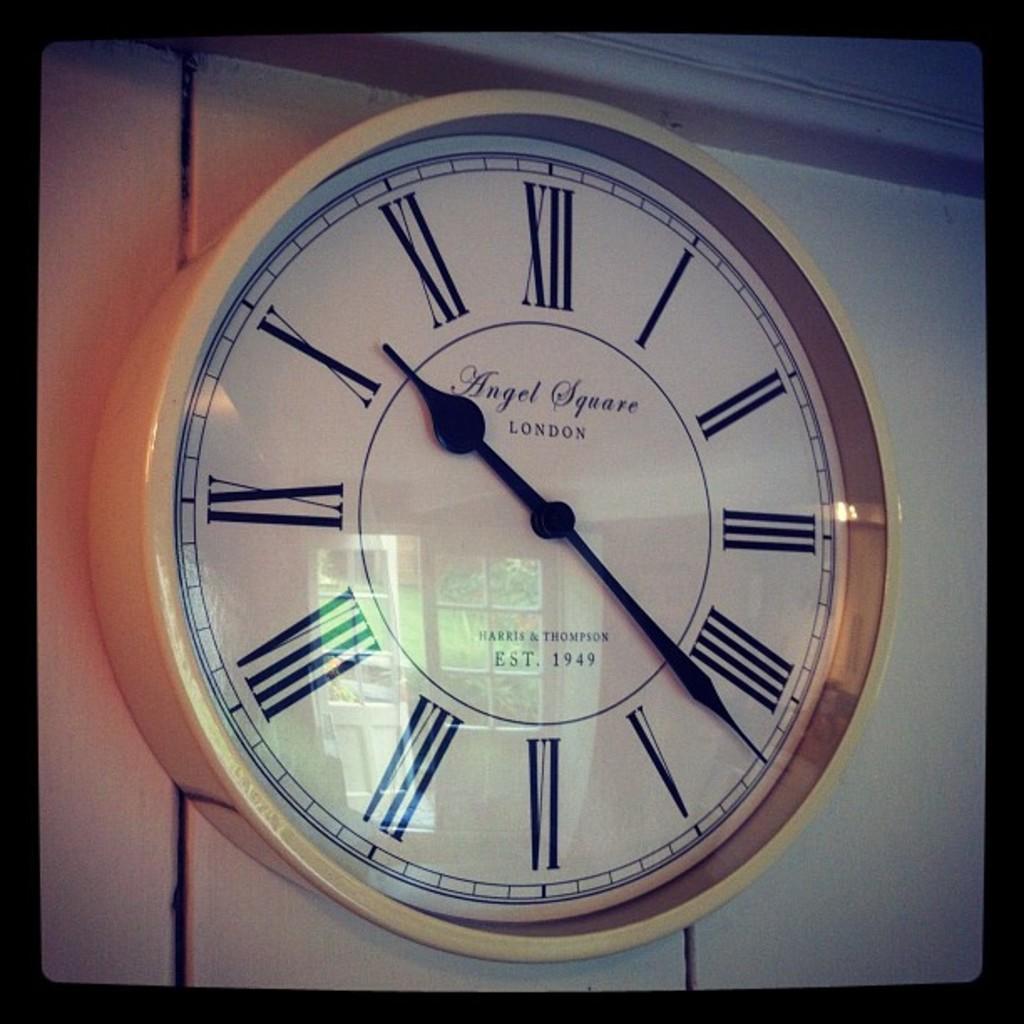What time is shown on the clock?
Give a very brief answer. 10:22. Where was this clock made?
Provide a short and direct response. London. 